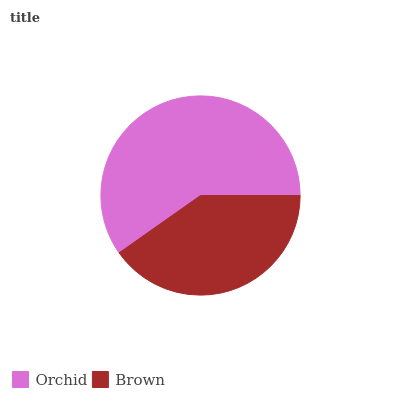Is Brown the minimum?
Answer yes or no. Yes. Is Orchid the maximum?
Answer yes or no. Yes. Is Brown the maximum?
Answer yes or no. No. Is Orchid greater than Brown?
Answer yes or no. Yes. Is Brown less than Orchid?
Answer yes or no. Yes. Is Brown greater than Orchid?
Answer yes or no. No. Is Orchid less than Brown?
Answer yes or no. No. Is Orchid the high median?
Answer yes or no. Yes. Is Brown the low median?
Answer yes or no. Yes. Is Brown the high median?
Answer yes or no. No. Is Orchid the low median?
Answer yes or no. No. 